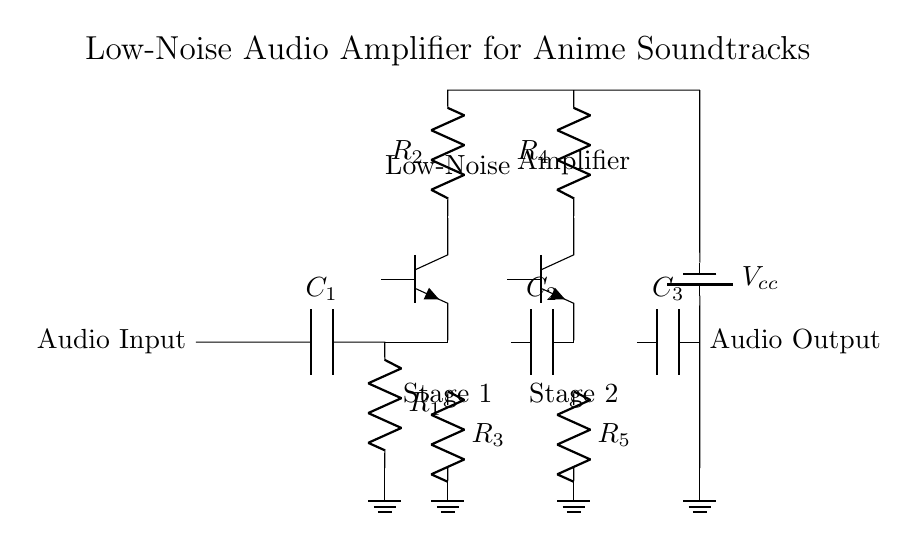What is the type of the first transistor in the circuit? The first transistor is labeled as Q1 in the diagram and is depicted as a NPN type, indicated by the Tnpn notation.
Answer: NPN What capacitors are used in the circuit? The circuit includes three capacitors labeled C1, C2, and C3, as indicated next to their symbols in the diagram.
Answer: C1, C2, C3 How many resistors are there in the first amplifier stage? In the first amplifier stage, there are two resistors labeled as R2 and R3, as shown in the connections.
Answer: 2 What is the role of capacitor C2 in the circuit? Capacitor C2 is positioned between the first and second amplifier stages, serving to couple the stages together while blocking DC voltage, thus allowing AC signals to pass.
Answer: Coupling What is the purpose of the power supply in the circuit? The power supply is needed to provide the necessary voltage (labeled Vcc) to power the components in the amplifier circuit for proper operation.
Answer: Power supply How are the audio input and output connected to the circuit? The audio input connects directly to the starting point of the circuit, while the audio output is taken from the end of the circuit after amplification, clearly indicated at the respective nodes.
Answer: Input to output 